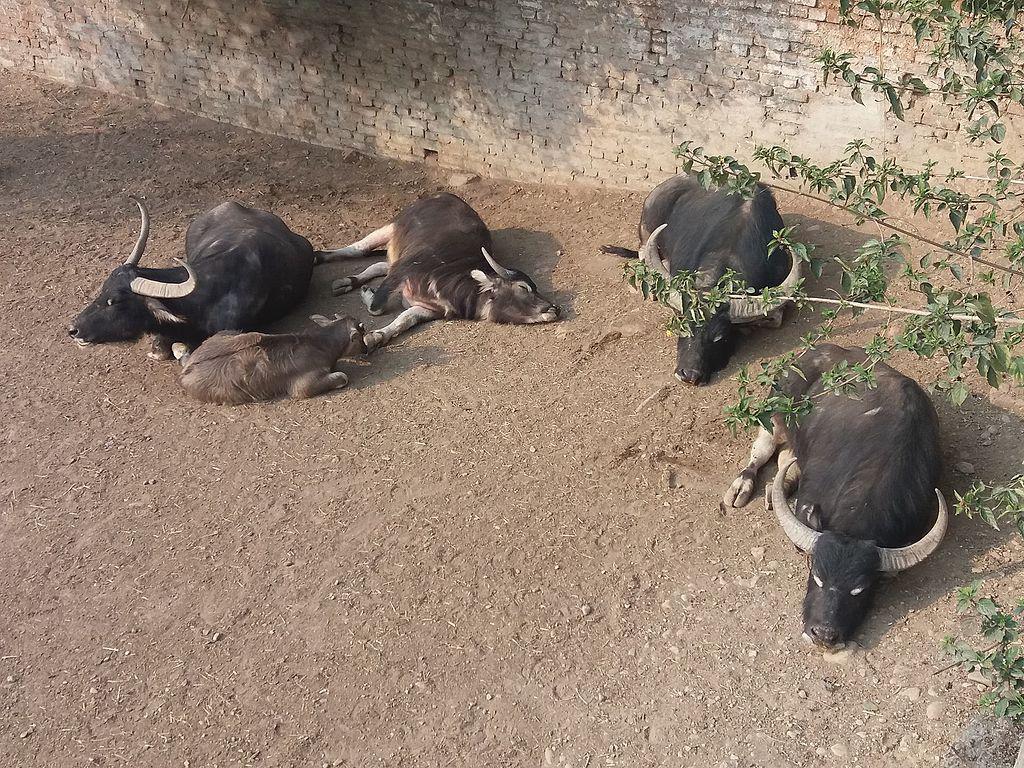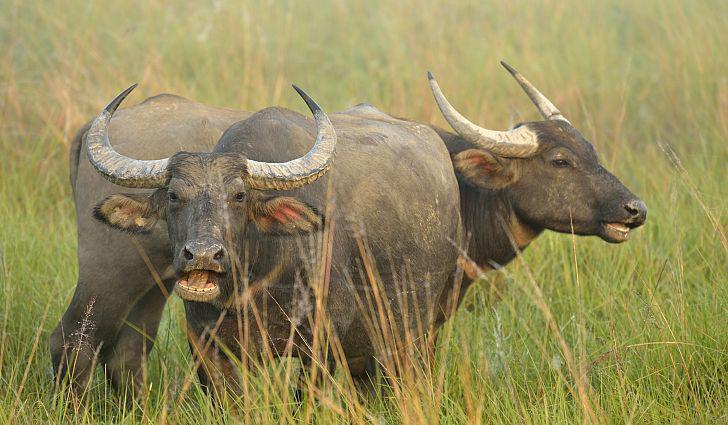The first image is the image on the left, the second image is the image on the right. For the images shown, is this caption "Exactly two hooved animals are shown in one image." true? Answer yes or no. Yes. The first image is the image on the left, the second image is the image on the right. Given the left and right images, does the statement "One of the images contains exactly two steer" hold true? Answer yes or no. Yes. 